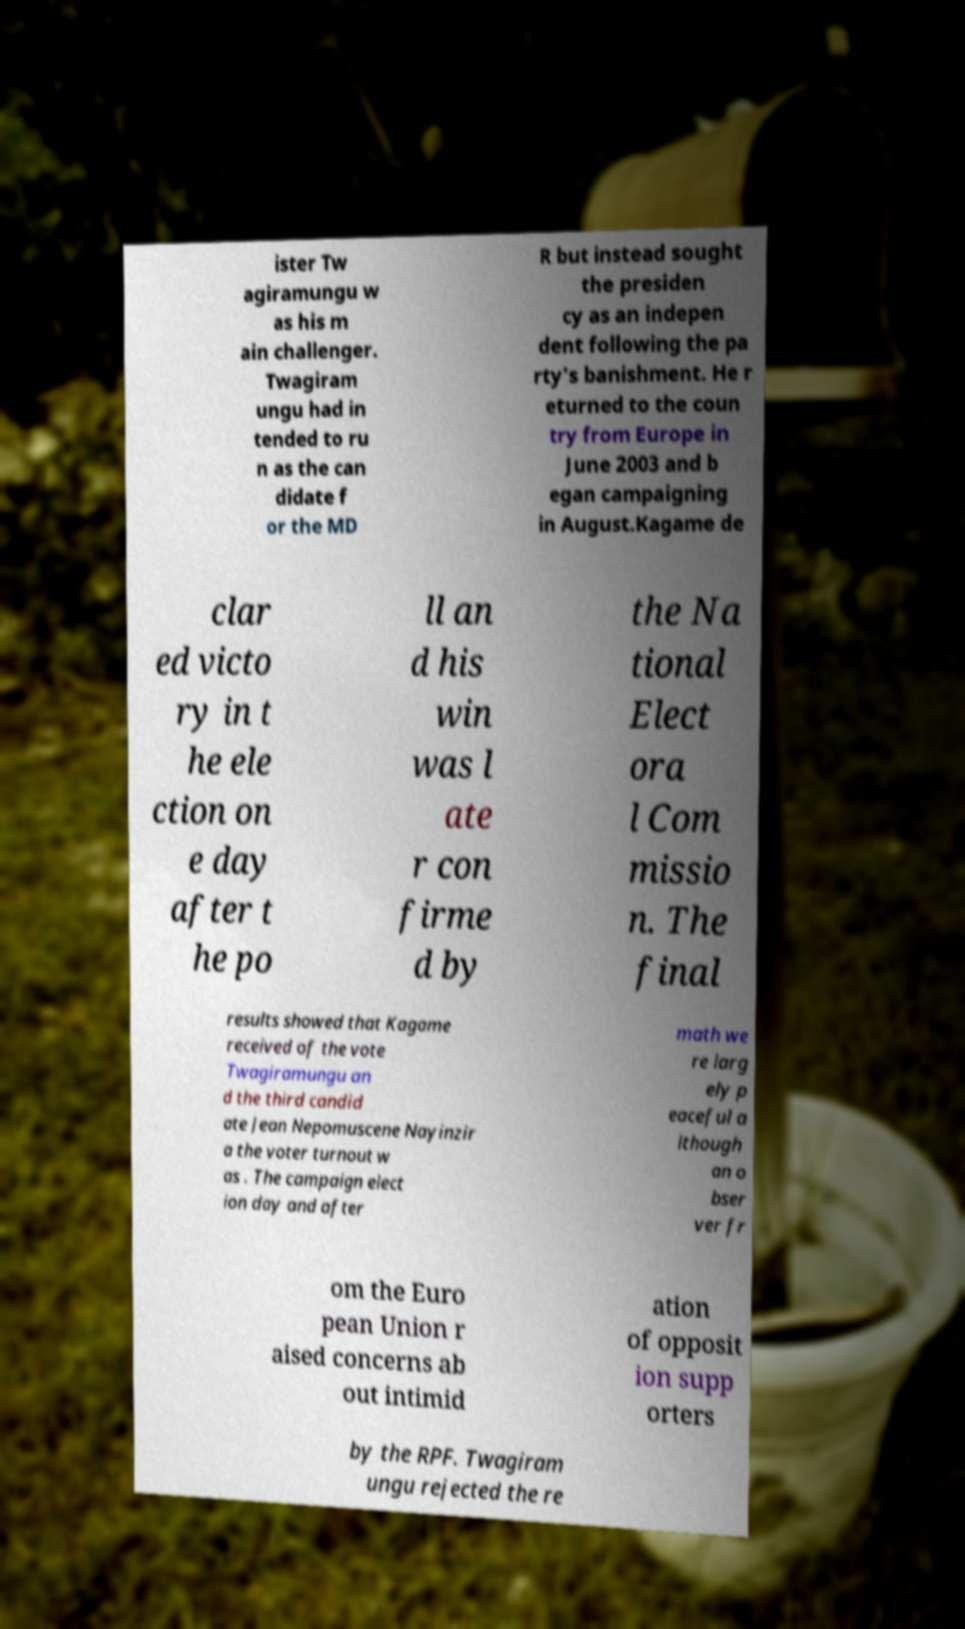Could you assist in decoding the text presented in this image and type it out clearly? ister Tw agiramungu w as his m ain challenger. Twagiram ungu had in tended to ru n as the can didate f or the MD R but instead sought the presiden cy as an indepen dent following the pa rty's banishment. He r eturned to the coun try from Europe in June 2003 and b egan campaigning in August.Kagame de clar ed victo ry in t he ele ction on e day after t he po ll an d his win was l ate r con firme d by the Na tional Elect ora l Com missio n. The final results showed that Kagame received of the vote Twagiramungu an d the third candid ate Jean Nepomuscene Nayinzir a the voter turnout w as . The campaign elect ion day and after math we re larg ely p eaceful a lthough an o bser ver fr om the Euro pean Union r aised concerns ab out intimid ation of opposit ion supp orters by the RPF. Twagiram ungu rejected the re 